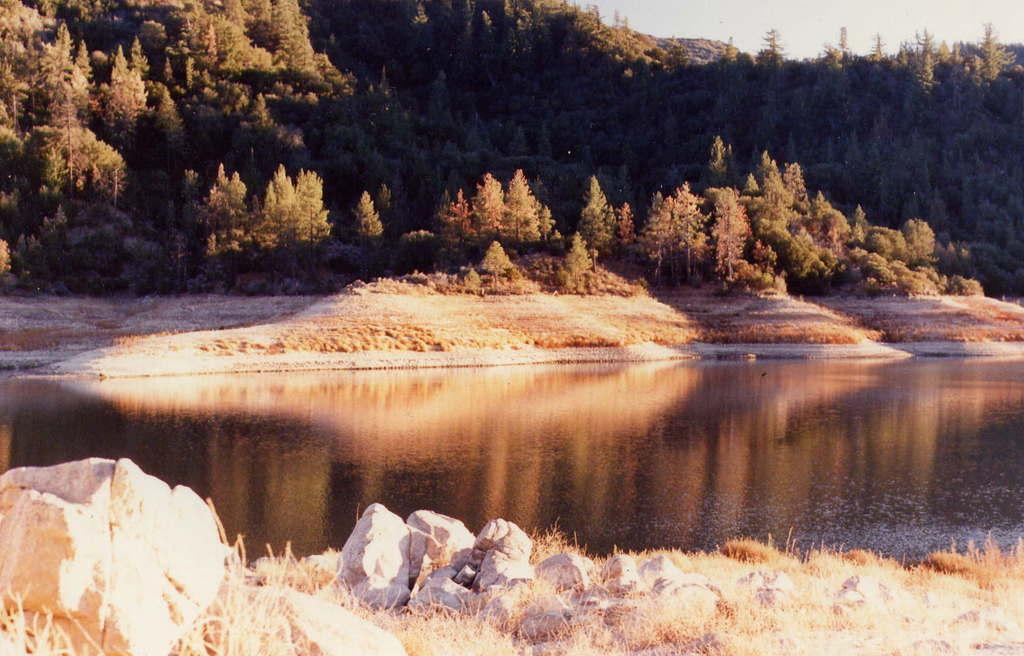What body of water is present in the image? There is a lake in the image. What can be seen reflected on the water surface? There is a reflection of trees and land on the water surface. What is visible in the sky in the image? The sky is visible in the image. How many trees are present in the image? There are many trees in the image. What type of vegetation is present besides trees? There are plants in the image. What type of medical advice can be heard from the doctor in the image? There is no doctor present in the image, so no medical advice can be heard. What type of sound quality can be expected from the acoustics in the image? There is no mention of acoustics or sound quality in the image, as it primarily focuses on the lake and its surroundings. 